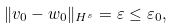Convert formula to latex. <formula><loc_0><loc_0><loc_500><loc_500>\| v _ { 0 } - w _ { 0 } \| _ { H ^ { s } } = \varepsilon \leq \varepsilon _ { 0 } ,</formula> 